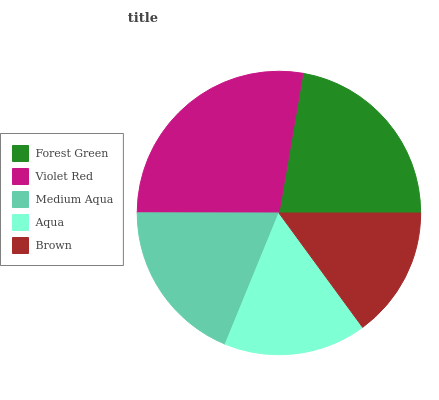Is Brown the minimum?
Answer yes or no. Yes. Is Violet Red the maximum?
Answer yes or no. Yes. Is Medium Aqua the minimum?
Answer yes or no. No. Is Medium Aqua the maximum?
Answer yes or no. No. Is Violet Red greater than Medium Aqua?
Answer yes or no. Yes. Is Medium Aqua less than Violet Red?
Answer yes or no. Yes. Is Medium Aqua greater than Violet Red?
Answer yes or no. No. Is Violet Red less than Medium Aqua?
Answer yes or no. No. Is Medium Aqua the high median?
Answer yes or no. Yes. Is Medium Aqua the low median?
Answer yes or no. Yes. Is Forest Green the high median?
Answer yes or no. No. Is Brown the low median?
Answer yes or no. No. 